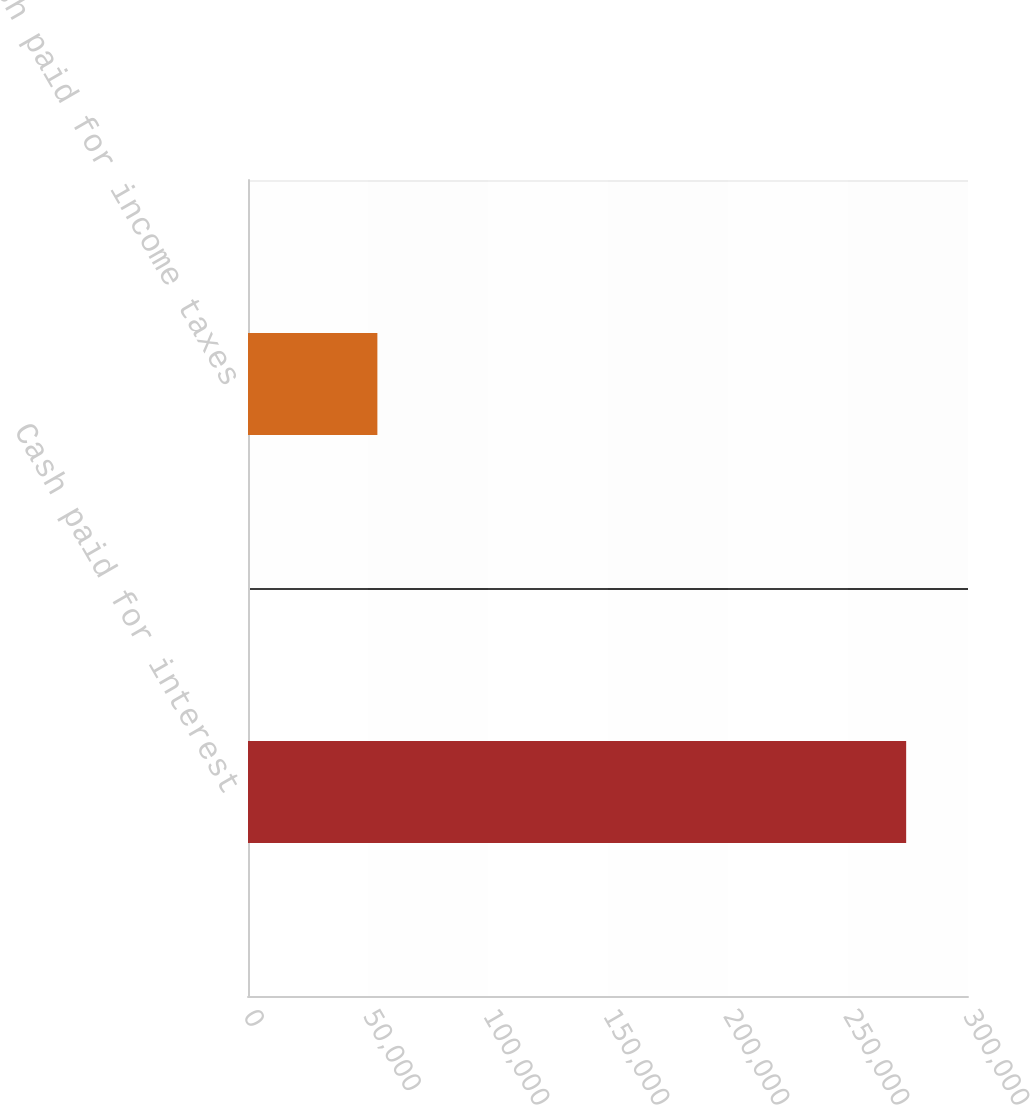Convert chart to OTSL. <chart><loc_0><loc_0><loc_500><loc_500><bar_chart><fcel>Cash paid for interest<fcel>Cash paid for income taxes<nl><fcel>274234<fcel>53909<nl></chart> 